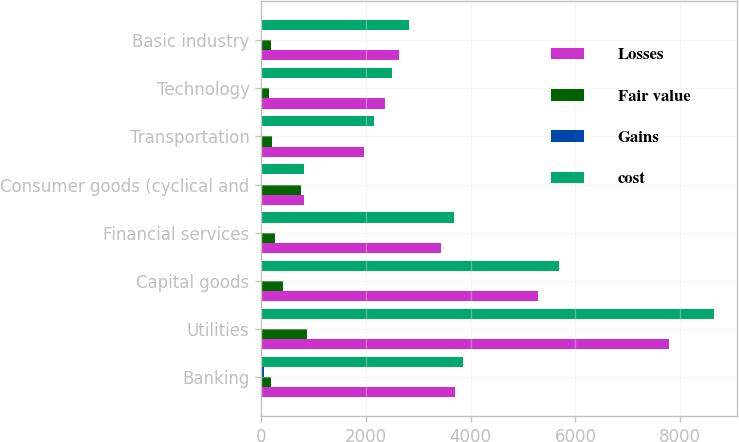Convert chart. <chart><loc_0><loc_0><loc_500><loc_500><stacked_bar_chart><ecel><fcel>Banking<fcel>Utilities<fcel>Capital goods<fcel>Financial services<fcel>Consumer goods (cyclical and<fcel>Transportation<fcel>Technology<fcel>Basic industry<nl><fcel>Losses<fcel>3707<fcel>7792<fcel>5281<fcel>3436<fcel>818.5<fcel>1960<fcel>2355<fcel>2626<nl><fcel>Fair value<fcel>195<fcel>879<fcel>424<fcel>257<fcel>758<fcel>203<fcel>147<fcel>191<nl><fcel>Gains<fcel>55<fcel>17<fcel>15<fcel>10<fcel>11<fcel>8<fcel>4<fcel>3<nl><fcel>cost<fcel>3847<fcel>8654<fcel>5690<fcel>3683<fcel>818.5<fcel>2155<fcel>2498<fcel>2814<nl></chart> 